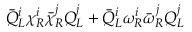Convert formula to latex. <formula><loc_0><loc_0><loc_500><loc_500>\bar { Q } _ { L } ^ { i } \chi _ { R } ^ { i } \bar { \chi } _ { R } ^ { j } Q _ { L } ^ { j } + \bar { Q } _ { L } ^ { i } \omega _ { R } ^ { i } \bar { \omega } _ { R } ^ { j } Q _ { L } ^ { j }</formula> 